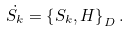Convert formula to latex. <formula><loc_0><loc_0><loc_500><loc_500>\dot { S _ { k } } = \left \{ S _ { k } , H \right \} _ { D } .</formula> 